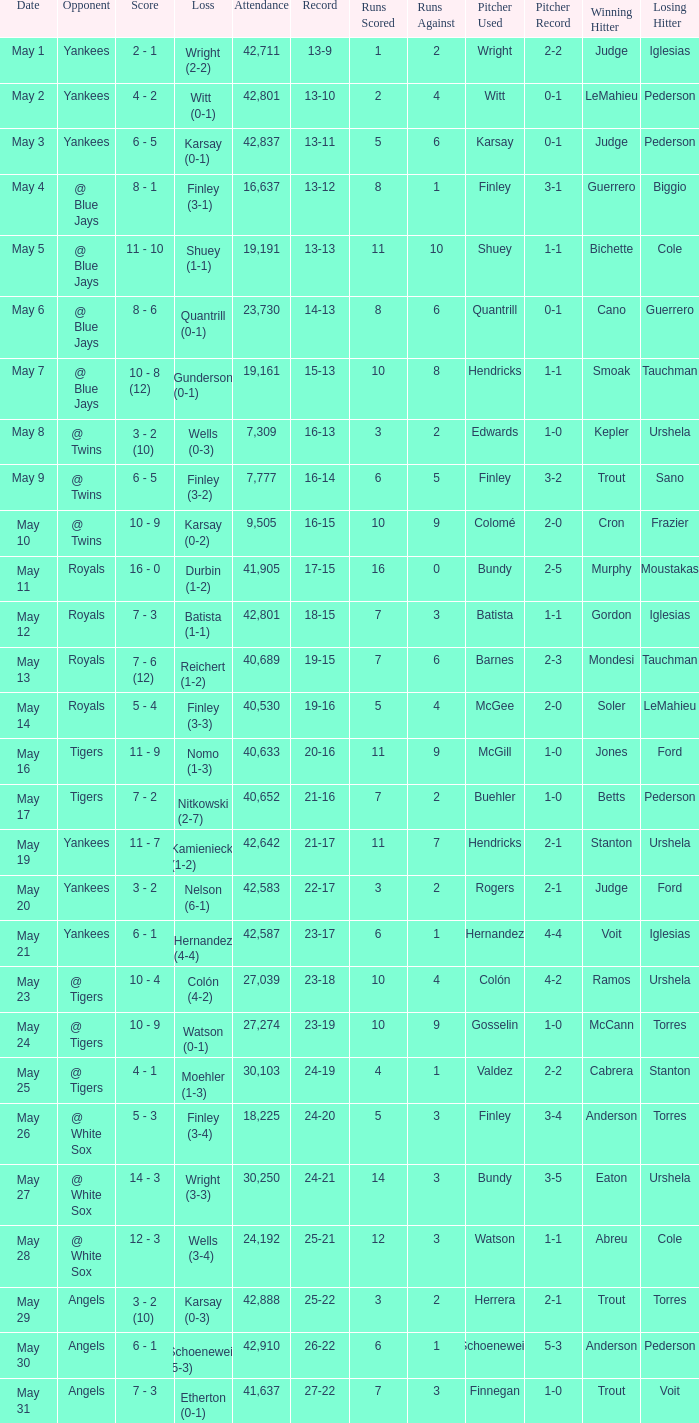What is the attendance for the game on May 25? 30103.0. 